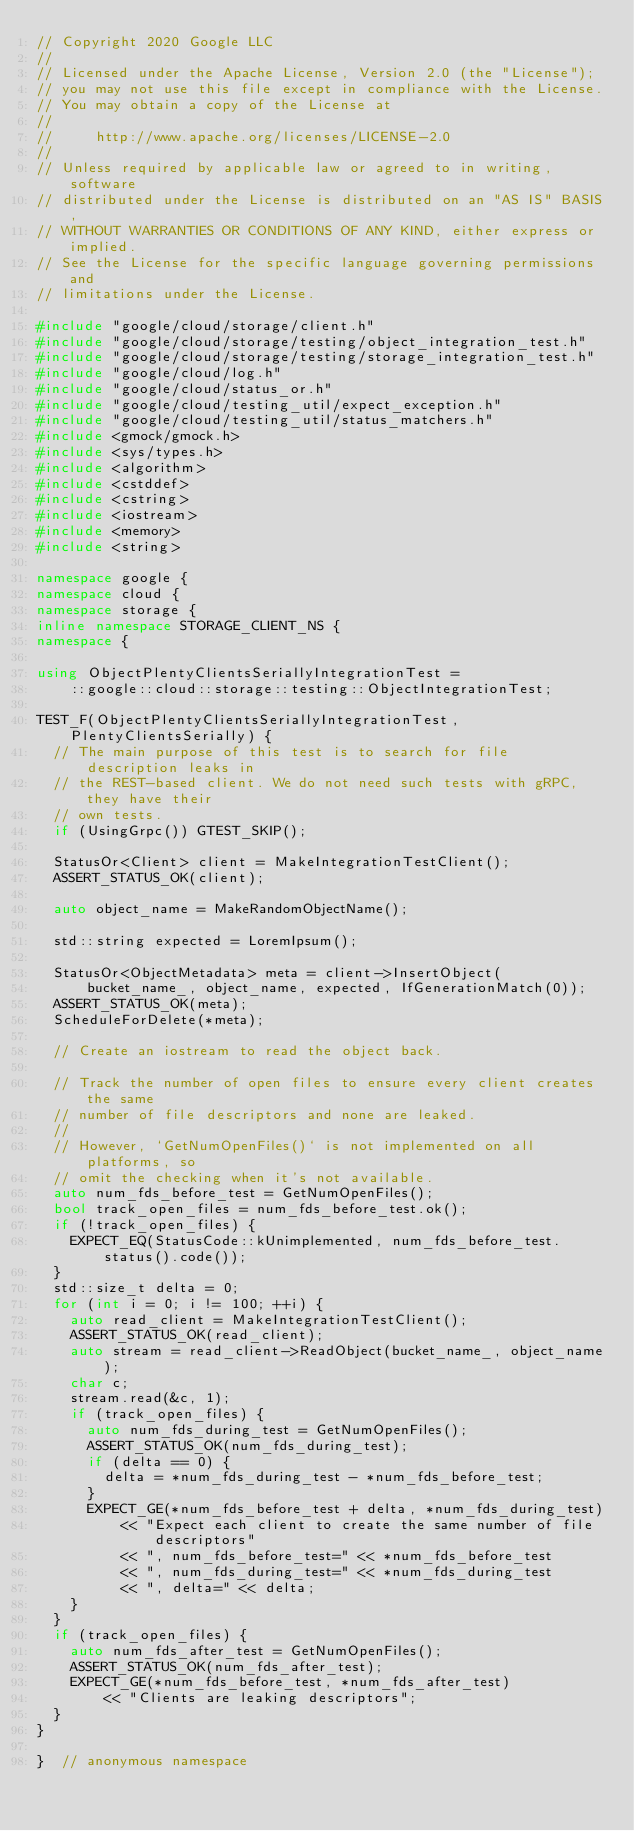Convert code to text. <code><loc_0><loc_0><loc_500><loc_500><_C++_>// Copyright 2020 Google LLC
//
// Licensed under the Apache License, Version 2.0 (the "License");
// you may not use this file except in compliance with the License.
// You may obtain a copy of the License at
//
//     http://www.apache.org/licenses/LICENSE-2.0
//
// Unless required by applicable law or agreed to in writing, software
// distributed under the License is distributed on an "AS IS" BASIS,
// WITHOUT WARRANTIES OR CONDITIONS OF ANY KIND, either express or implied.
// See the License for the specific language governing permissions and
// limitations under the License.

#include "google/cloud/storage/client.h"
#include "google/cloud/storage/testing/object_integration_test.h"
#include "google/cloud/storage/testing/storage_integration_test.h"
#include "google/cloud/log.h"
#include "google/cloud/status_or.h"
#include "google/cloud/testing_util/expect_exception.h"
#include "google/cloud/testing_util/status_matchers.h"
#include <gmock/gmock.h>
#include <sys/types.h>
#include <algorithm>
#include <cstddef>
#include <cstring>
#include <iostream>
#include <memory>
#include <string>

namespace google {
namespace cloud {
namespace storage {
inline namespace STORAGE_CLIENT_NS {
namespace {

using ObjectPlentyClientsSeriallyIntegrationTest =
    ::google::cloud::storage::testing::ObjectIntegrationTest;

TEST_F(ObjectPlentyClientsSeriallyIntegrationTest, PlentyClientsSerially) {
  // The main purpose of this test is to search for file description leaks in
  // the REST-based client. We do not need such tests with gRPC, they have their
  // own tests.
  if (UsingGrpc()) GTEST_SKIP();

  StatusOr<Client> client = MakeIntegrationTestClient();
  ASSERT_STATUS_OK(client);

  auto object_name = MakeRandomObjectName();

  std::string expected = LoremIpsum();

  StatusOr<ObjectMetadata> meta = client->InsertObject(
      bucket_name_, object_name, expected, IfGenerationMatch(0));
  ASSERT_STATUS_OK(meta);
  ScheduleForDelete(*meta);

  // Create an iostream to read the object back.

  // Track the number of open files to ensure every client creates the same
  // number of file descriptors and none are leaked.
  //
  // However, `GetNumOpenFiles()` is not implemented on all platforms, so
  // omit the checking when it's not available.
  auto num_fds_before_test = GetNumOpenFiles();
  bool track_open_files = num_fds_before_test.ok();
  if (!track_open_files) {
    EXPECT_EQ(StatusCode::kUnimplemented, num_fds_before_test.status().code());
  }
  std::size_t delta = 0;
  for (int i = 0; i != 100; ++i) {
    auto read_client = MakeIntegrationTestClient();
    ASSERT_STATUS_OK(read_client);
    auto stream = read_client->ReadObject(bucket_name_, object_name);
    char c;
    stream.read(&c, 1);
    if (track_open_files) {
      auto num_fds_during_test = GetNumOpenFiles();
      ASSERT_STATUS_OK(num_fds_during_test);
      if (delta == 0) {
        delta = *num_fds_during_test - *num_fds_before_test;
      }
      EXPECT_GE(*num_fds_before_test + delta, *num_fds_during_test)
          << "Expect each client to create the same number of file descriptors"
          << ", num_fds_before_test=" << *num_fds_before_test
          << ", num_fds_during_test=" << *num_fds_during_test
          << ", delta=" << delta;
    }
  }
  if (track_open_files) {
    auto num_fds_after_test = GetNumOpenFiles();
    ASSERT_STATUS_OK(num_fds_after_test);
    EXPECT_GE(*num_fds_before_test, *num_fds_after_test)
        << "Clients are leaking descriptors";
  }
}

}  // anonymous namespace</code> 